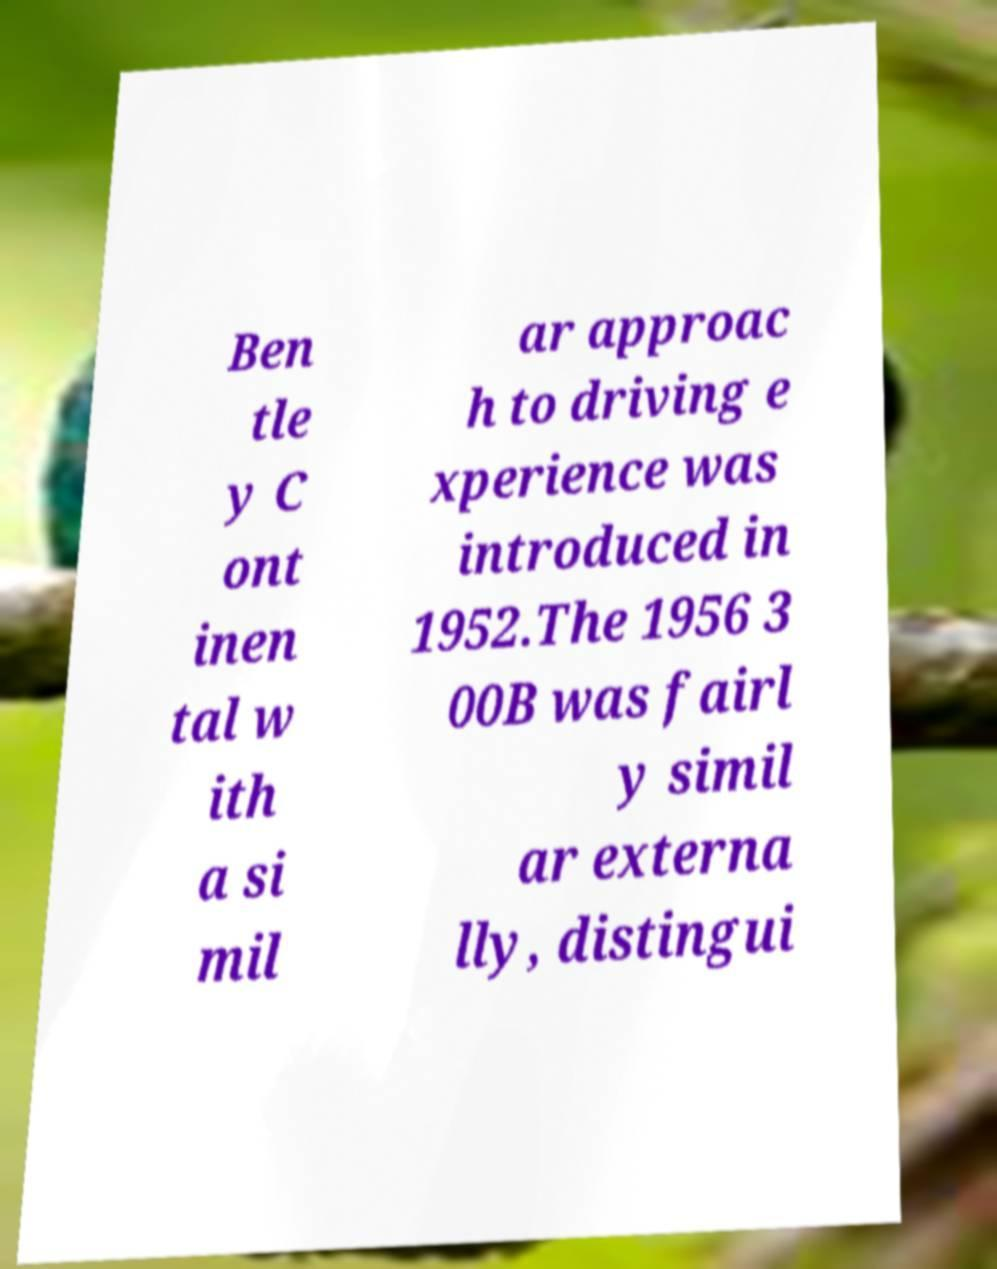What messages or text are displayed in this image? I need them in a readable, typed format. Ben tle y C ont inen tal w ith a si mil ar approac h to driving e xperience was introduced in 1952.The 1956 3 00B was fairl y simil ar externa lly, distingui 